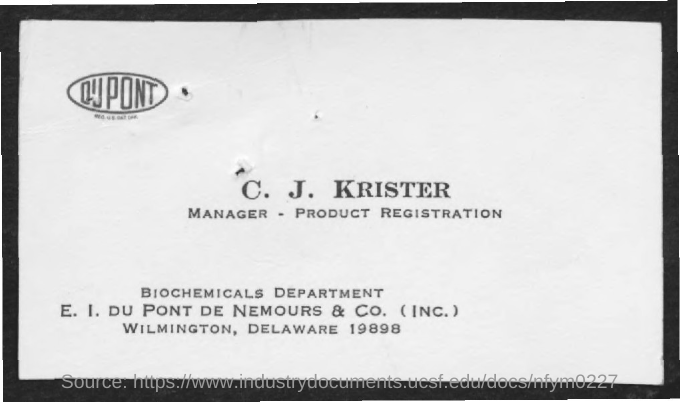What is the designation of C. J. KRISTER?
Ensure brevity in your answer.  MANAGER . PRODUCT REGISTRATION. What is the name of the department mentioned in the given form ?
Offer a terse response. Biochemicals department. 